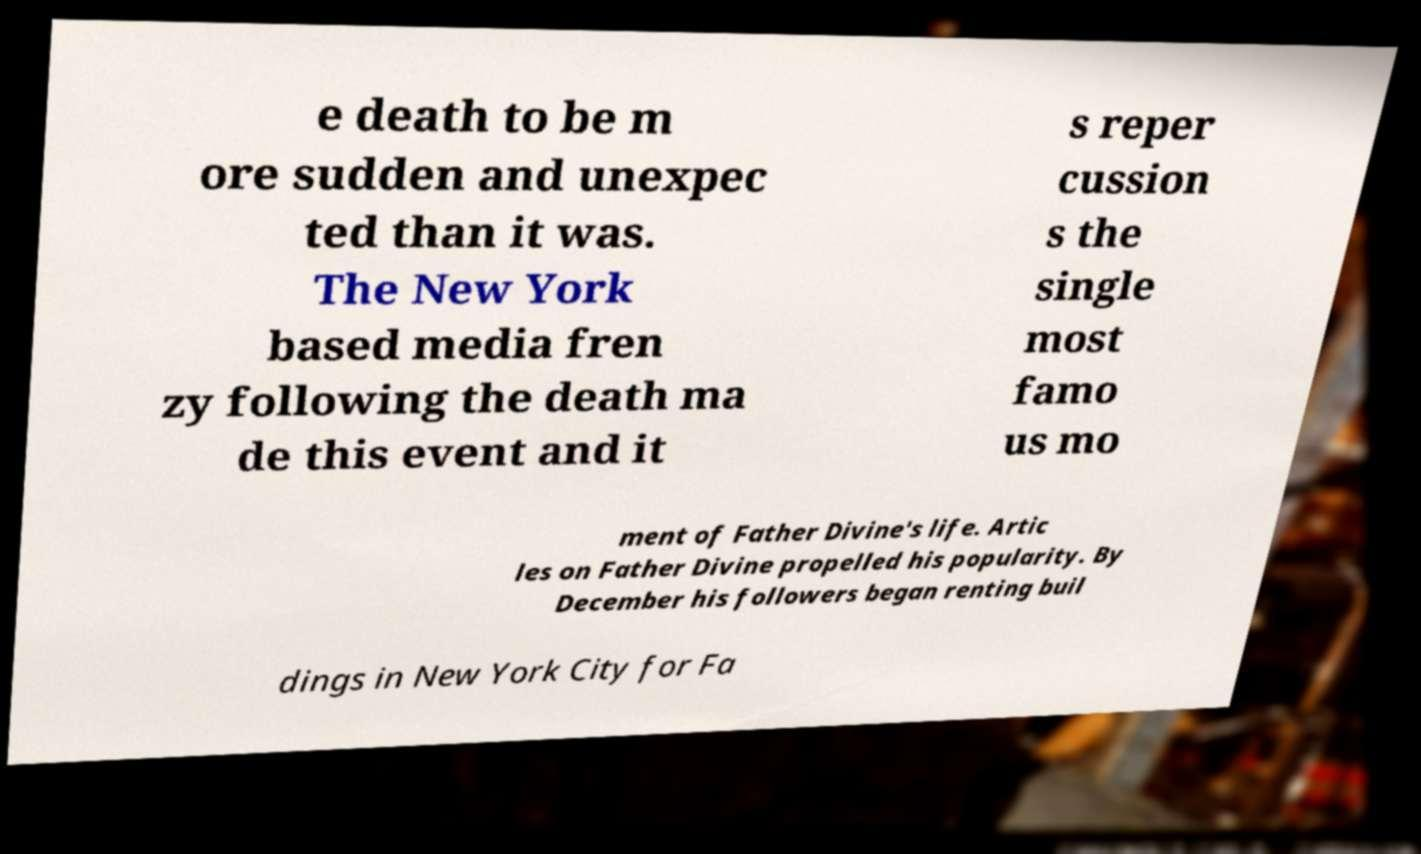What messages or text are displayed in this image? I need them in a readable, typed format. e death to be m ore sudden and unexpec ted than it was. The New York based media fren zy following the death ma de this event and it s reper cussion s the single most famo us mo ment of Father Divine's life. Artic les on Father Divine propelled his popularity. By December his followers began renting buil dings in New York City for Fa 